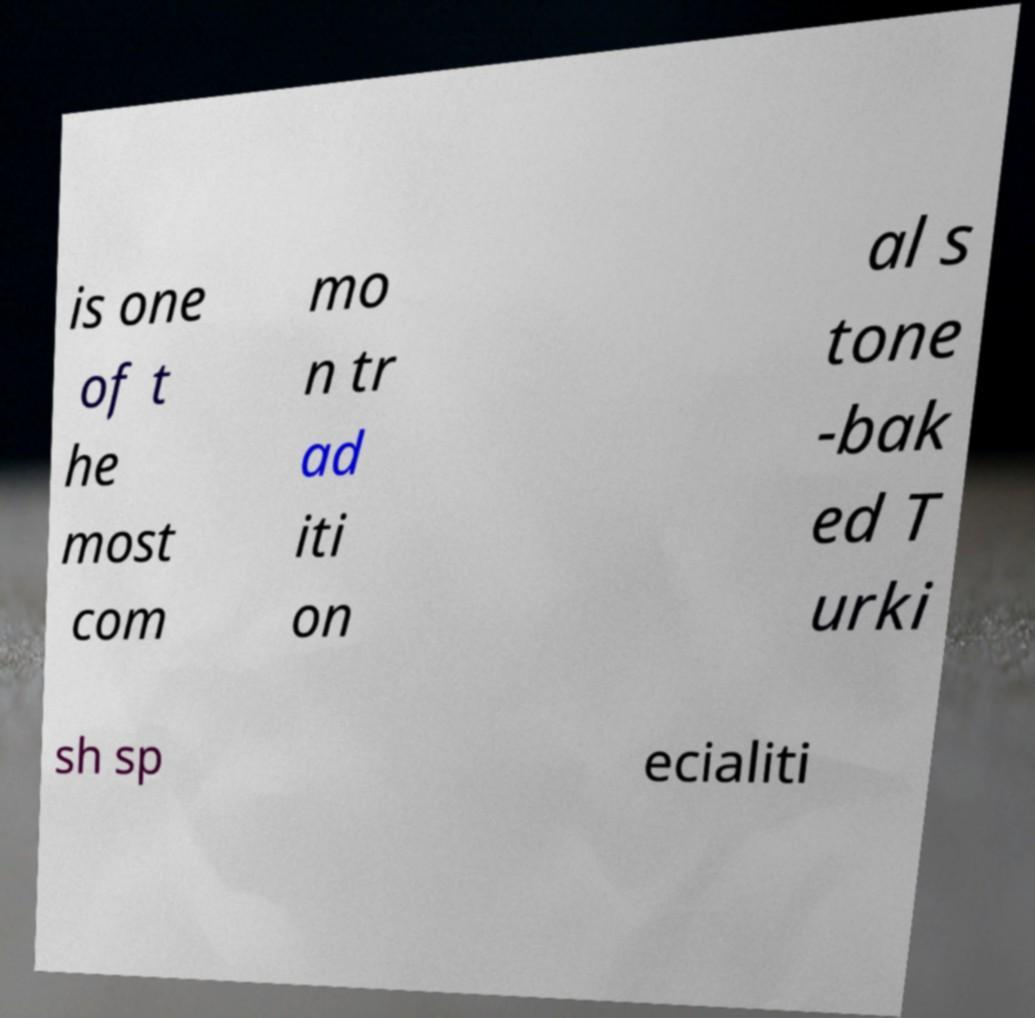Could you extract and type out the text from this image? is one of t he most com mo n tr ad iti on al s tone -bak ed T urki sh sp ecialiti 